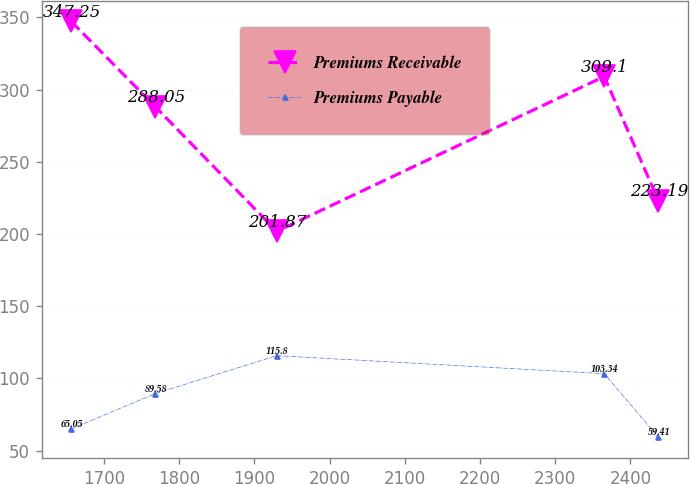Convert chart to OTSL. <chart><loc_0><loc_0><loc_500><loc_500><line_chart><ecel><fcel>Premiums Receivable<fcel>Premiums Payable<nl><fcel>1656.58<fcel>347.25<fcel>65.05<nl><fcel>1768.59<fcel>288.05<fcel>89.58<nl><fcel>1929.87<fcel>201.87<fcel>115.8<nl><fcel>2365.12<fcel>309.1<fcel>103.34<nl><fcel>2437.08<fcel>223.19<fcel>59.41<nl></chart> 